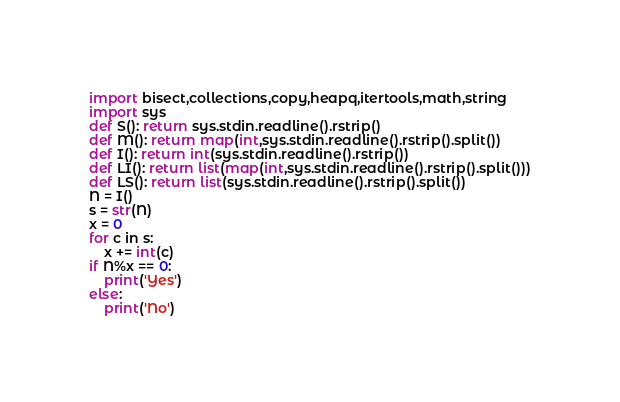Convert code to text. <code><loc_0><loc_0><loc_500><loc_500><_Python_>import bisect,collections,copy,heapq,itertools,math,string
import sys
def S(): return sys.stdin.readline().rstrip()
def M(): return map(int,sys.stdin.readline().rstrip().split())
def I(): return int(sys.stdin.readline().rstrip())
def LI(): return list(map(int,sys.stdin.readline().rstrip().split()))
def LS(): return list(sys.stdin.readline().rstrip().split())
N = I()
s = str(N)
x = 0
for c in s:
    x += int(c)
if N%x == 0:
    print('Yes')
else:
    print('No')</code> 